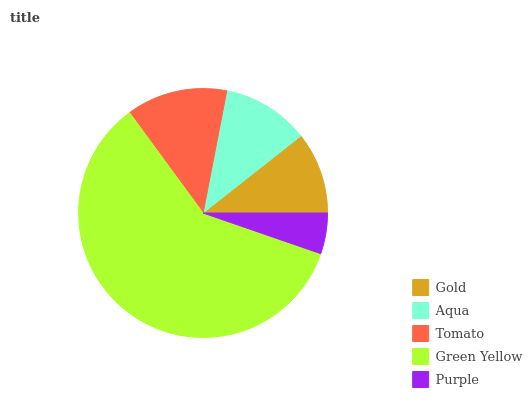Is Purple the minimum?
Answer yes or no. Yes. Is Green Yellow the maximum?
Answer yes or no. Yes. Is Aqua the minimum?
Answer yes or no. No. Is Aqua the maximum?
Answer yes or no. No. Is Aqua greater than Gold?
Answer yes or no. Yes. Is Gold less than Aqua?
Answer yes or no. Yes. Is Gold greater than Aqua?
Answer yes or no. No. Is Aqua less than Gold?
Answer yes or no. No. Is Aqua the high median?
Answer yes or no. Yes. Is Aqua the low median?
Answer yes or no. Yes. Is Green Yellow the high median?
Answer yes or no. No. Is Purple the low median?
Answer yes or no. No. 